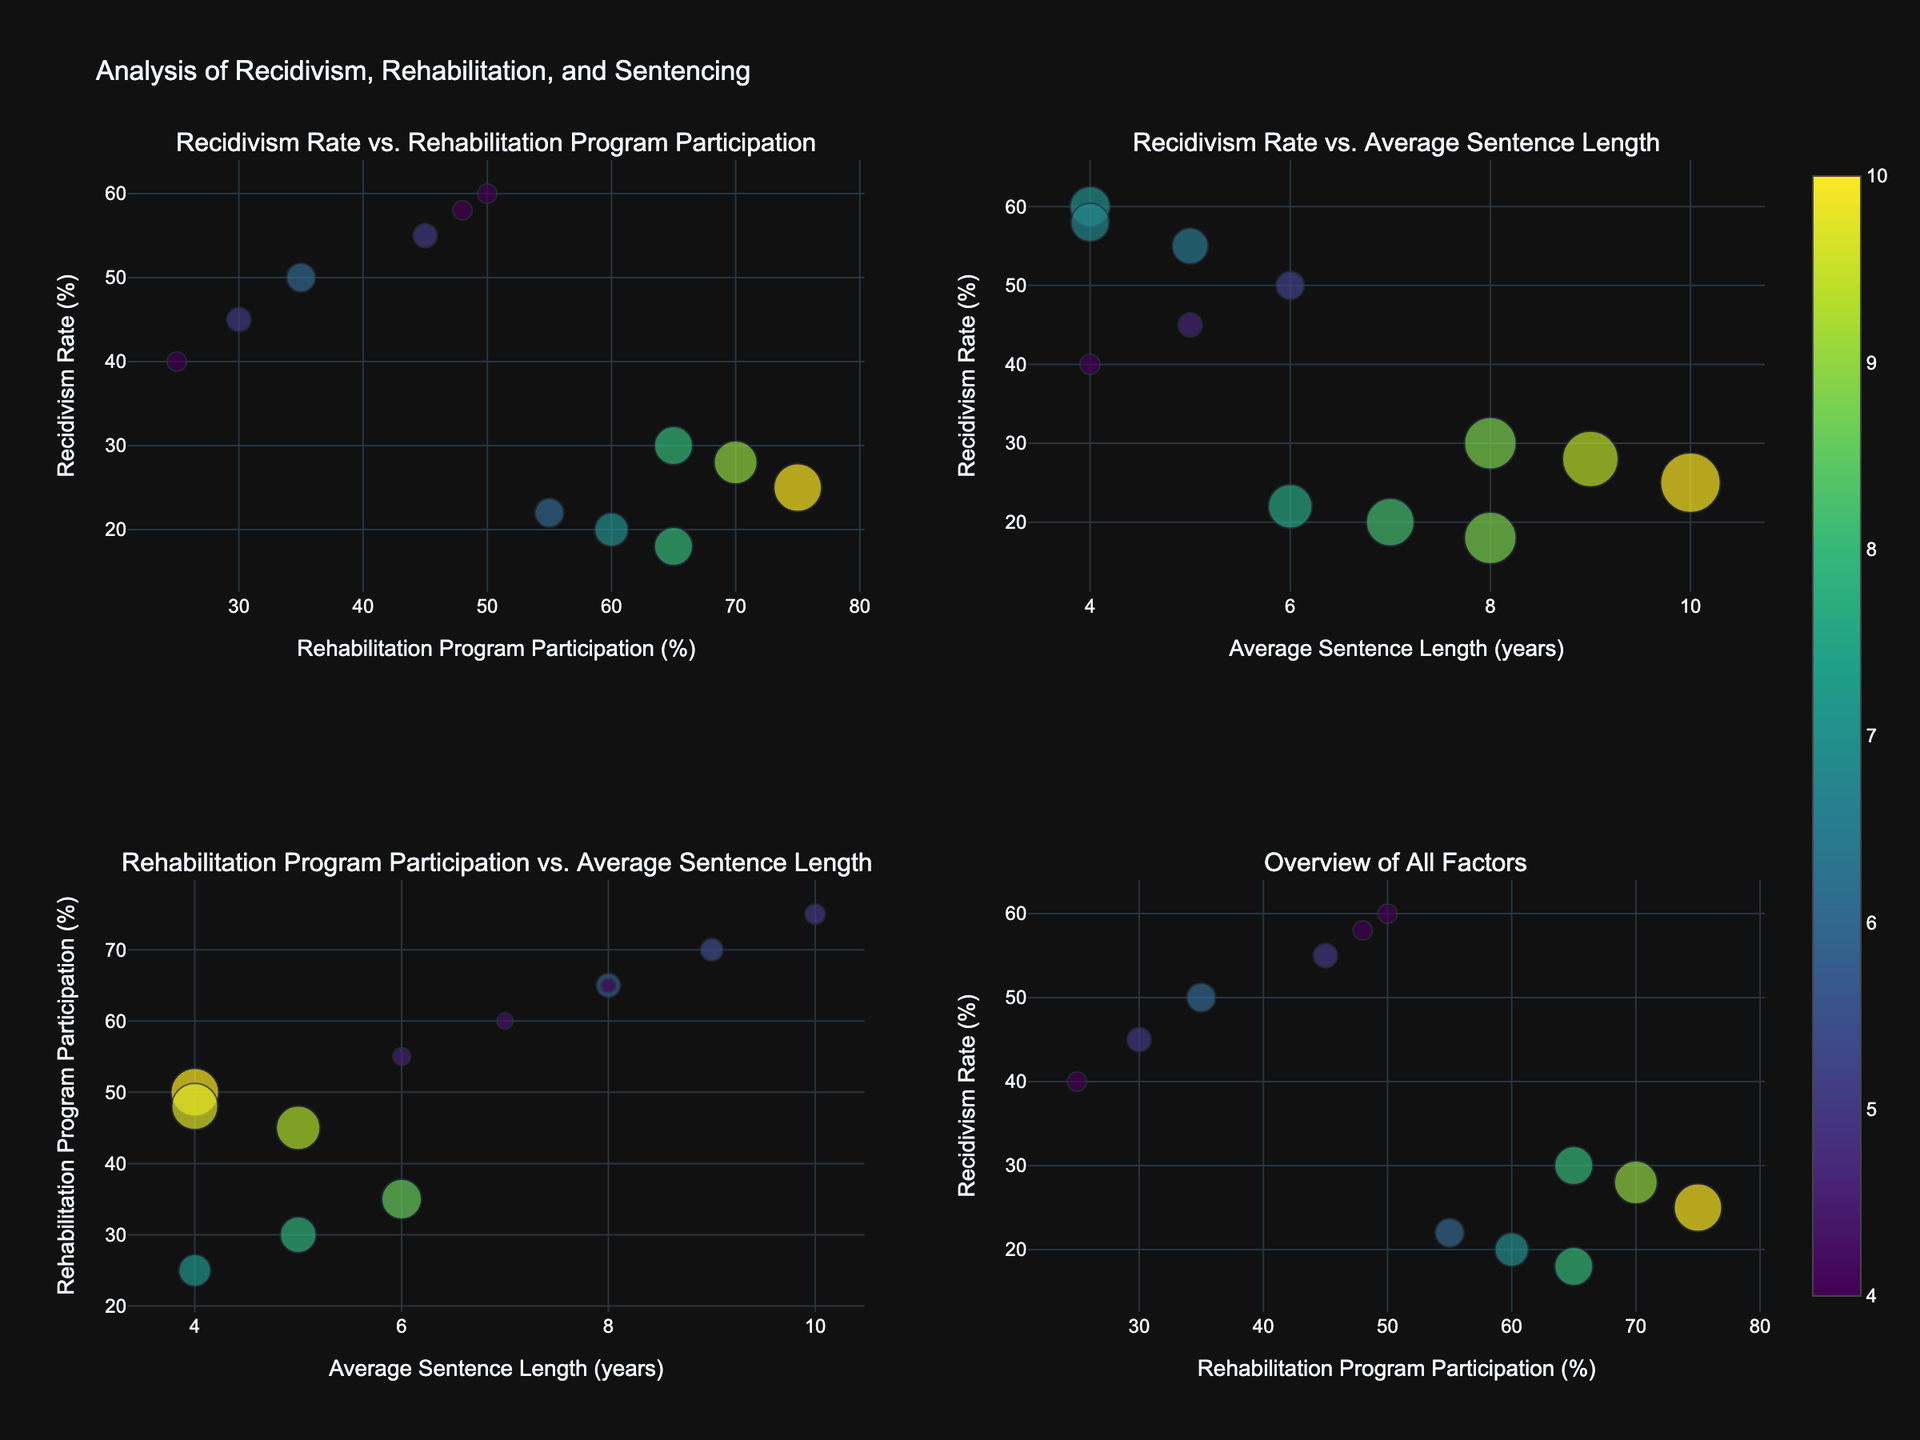What are the titles of the subplots? The titles of the subplots are clearly labeled at the top of each subplot, which are: "Recidivism Rate vs. Rehabilitation Program Participation," "Recidivism Rate vs. Average Sentence Length," "Rehabilitation Program Participation vs. Average Sentence Length," and "Overview of All Factors."
Answer: "Recidivism Rate vs. Rehabilitation Program Participation," "Recidivism Rate vs. Average Sentence Length," "Rehabilitation Program Participation vs. Average Sentence Length," "Overview of All Factors." Which jurisdiction has the highest recidivism rate for Drug Offense? Locate the data points for Drug Offense and find the jurisdiction with the highest recidivism rate. For Drug Offenses, the rates are 60% (Nevada), 55% (Colorado), and 58% (Arizona). The highest is Nevada.
Answer: Nevada Compare the average sentence length for Burglary in New York and California. Which state has a longer average sentence? Identify the bubbles representing Burglary in New York and California in the subplots. Average sentence lengths are labeled with the bubble sizes. New York has an average sentence length of 5 years, while California has 6 years.
Answer: California What is the relationship between Rehabilitation Program Participation and Recidivism Rate in the "Overview of All Factors" subplot? Examine the "Overview of All Factors" subplot. The general trend can be observed between the two axes. There does not appear to be a clear relationship, as the recidivism rate does not consistently decrease or increase with rehabilitation program participation.
Answer: No clear relationship Which offense has the lowest recidivism rate across all jurisdictions? Look at the y-axis of "Recidivism Rate" across all the subplots and identify the lowest rate. Fraud has the lowest recidivism rates (20%, 22%, 18%) compared to other offenses.
Answer: Fraud How does rehabilitation program participation compare between Assault and Fraud offenses? Identify the bubbles in the Rehabilitation Program Participation axis for both Assault and Fraud offenses. Assault offenses have participation rates of 75%, 65%, and 70%, whereas Fraud offenses have 60%, 55%, and 65%. Assault generally has higher participation rates.
Answer: Assault has higher participation rates Which Criminal Offense shows zero correlation between Recidivism Rate and Rehabilitation Program Participation? Compare the points on the "Recidivism Rate vs. Rehabilitation Program Participation" plot and look for offenses with scattered points. Burglary points are quite dispersed, indicating low correlation.
Answer: Burglary What can be inferred about the impact of average sentence length on recidivism rates for Assault offenses? Observe the "Recidivism Rate vs. Average Sentence Length" plot, focusing on Assault offenses. Despite higher sentence lengths (8-10 years), recidivism rates (25-30%) remain relatively low.
Answer: Longer sentences may reduce recidivism rates for Assault Which jurisdiction has the highest participation in rehabilitation programs for Fraud? Identify the points representing Fraud on the "Rehabilitation Program Participation" axis. The highest participation rate for Fraud is in Oregon at 65%.
Answer: Oregon 